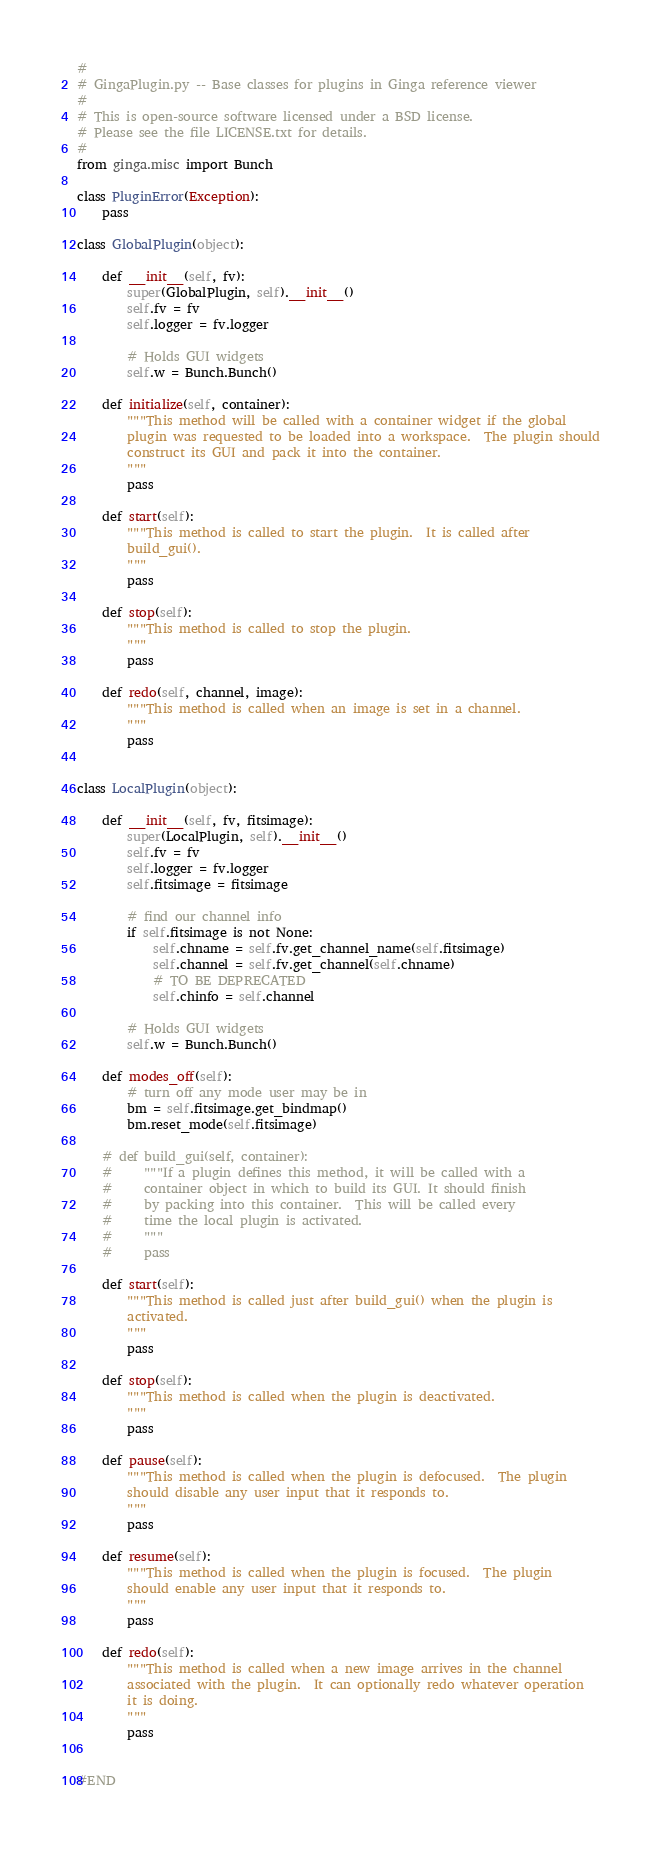Convert code to text. <code><loc_0><loc_0><loc_500><loc_500><_Python_>#
# GingaPlugin.py -- Base classes for plugins in Ginga reference viewer
#
# This is open-source software licensed under a BSD license.
# Please see the file LICENSE.txt for details.
#
from ginga.misc import Bunch

class PluginError(Exception):
    pass

class GlobalPlugin(object):

    def __init__(self, fv):
        super(GlobalPlugin, self).__init__()
        self.fv = fv
        self.logger = fv.logger

        # Holds GUI widgets
        self.w = Bunch.Bunch()

    def initialize(self, container):
        """This method will be called with a container widget if the global
        plugin was requested to be loaded into a workspace.  The plugin should
        construct its GUI and pack it into the container.
        """
        pass

    def start(self):
        """This method is called to start the plugin.  It is called after
        build_gui().
        """
        pass

    def stop(self):
        """This method is called to stop the plugin.
        """
        pass

    def redo(self, channel, image):
        """This method is called when an image is set in a channel.
        """
        pass


class LocalPlugin(object):

    def __init__(self, fv, fitsimage):
        super(LocalPlugin, self).__init__()
        self.fv = fv
        self.logger = fv.logger
        self.fitsimage = fitsimage

        # find our channel info
        if self.fitsimage is not None:
            self.chname = self.fv.get_channel_name(self.fitsimage)
            self.channel = self.fv.get_channel(self.chname)
            # TO BE DEPRECATED
            self.chinfo = self.channel

        # Holds GUI widgets
        self.w = Bunch.Bunch()

    def modes_off(self):
        # turn off any mode user may be in
        bm = self.fitsimage.get_bindmap()
        bm.reset_mode(self.fitsimage)

    # def build_gui(self, container):
    #     """If a plugin defines this method, it will be called with a
    #     container object in which to build its GUI. It should finish
    #     by packing into this container.  This will be called every
    #     time the local plugin is activated.
    #     """
    #     pass

    def start(self):
        """This method is called just after build_gui() when the plugin is
        activated.
        """
        pass

    def stop(self):
        """This method is called when the plugin is deactivated.
        """
        pass

    def pause(self):
        """This method is called when the plugin is defocused.  The plugin
        should disable any user input that it responds to.
        """
        pass

    def resume(self):
        """This method is called when the plugin is focused.  The plugin
        should enable any user input that it responds to.
        """
        pass

    def redo(self):
        """This method is called when a new image arrives in the channel
        associated with the plugin.  It can optionally redo whatever operation
        it is doing.
        """
        pass


#END
</code> 